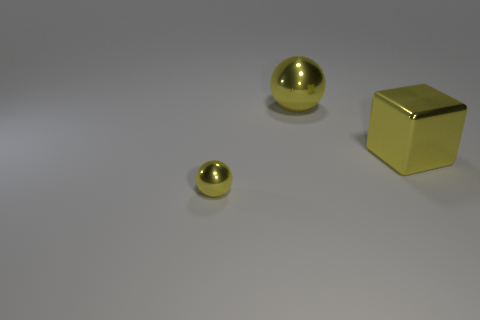How many things are either tiny yellow rubber things or yellow metallic spheres left of the large yellow metal ball?
Provide a short and direct response. 1. What size is the other yellow ball that is the same material as the large yellow ball?
Offer a terse response. Small. Are there more shiny spheres in front of the big yellow sphere than big green matte spheres?
Provide a succinct answer. Yes. What is the size of the thing that is both behind the small yellow object and on the left side of the yellow cube?
Keep it short and to the point. Large. What is the material of the other object that is the same shape as the small yellow thing?
Make the answer very short. Metal. There is a yellow ball that is behind the yellow metallic block; is it the same size as the cube?
Offer a very short reply. Yes. What color is the object that is both behind the small thing and to the left of the big shiny block?
Ensure brevity in your answer.  Yellow. How many shiny objects are in front of the ball to the right of the small metallic ball?
Offer a very short reply. 2. Do the tiny metallic object and the yellow shiny thing to the right of the big shiny ball have the same shape?
Your response must be concise. No. The shiny ball to the left of the metal ball behind the ball that is in front of the large metallic block is what color?
Your response must be concise. Yellow. 